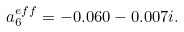Convert formula to latex. <formula><loc_0><loc_0><loc_500><loc_500>a _ { 6 } ^ { e f f } = - 0 . 0 6 0 - 0 . 0 0 7 i .</formula> 